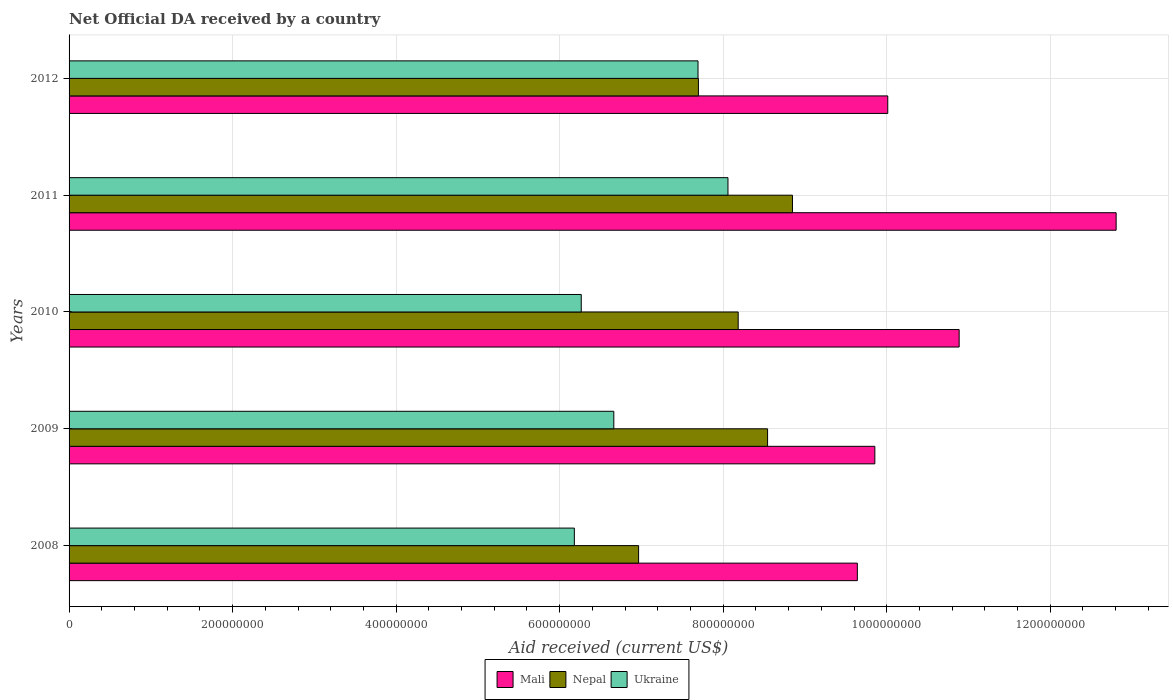How many different coloured bars are there?
Offer a terse response. 3. How many groups of bars are there?
Keep it short and to the point. 5. Are the number of bars per tick equal to the number of legend labels?
Provide a succinct answer. Yes. Are the number of bars on each tick of the Y-axis equal?
Provide a succinct answer. Yes. How many bars are there on the 4th tick from the bottom?
Keep it short and to the point. 3. What is the net official development assistance aid received in Ukraine in 2012?
Your response must be concise. 7.69e+08. Across all years, what is the maximum net official development assistance aid received in Nepal?
Your answer should be compact. 8.85e+08. Across all years, what is the minimum net official development assistance aid received in Ukraine?
Offer a very short reply. 6.18e+08. What is the total net official development assistance aid received in Ukraine in the graph?
Give a very brief answer. 3.49e+09. What is the difference between the net official development assistance aid received in Mali in 2008 and that in 2012?
Offer a terse response. -3.72e+07. What is the difference between the net official development assistance aid received in Mali in 2011 and the net official development assistance aid received in Nepal in 2012?
Your answer should be very brief. 5.11e+08. What is the average net official development assistance aid received in Mali per year?
Your answer should be very brief. 1.06e+09. In the year 2010, what is the difference between the net official development assistance aid received in Ukraine and net official development assistance aid received in Mali?
Your response must be concise. -4.62e+08. What is the ratio of the net official development assistance aid received in Mali in 2011 to that in 2012?
Your answer should be very brief. 1.28. Is the difference between the net official development assistance aid received in Ukraine in 2008 and 2012 greater than the difference between the net official development assistance aid received in Mali in 2008 and 2012?
Your response must be concise. No. What is the difference between the highest and the second highest net official development assistance aid received in Ukraine?
Ensure brevity in your answer.  3.66e+07. What is the difference between the highest and the lowest net official development assistance aid received in Ukraine?
Offer a terse response. 1.88e+08. In how many years, is the net official development assistance aid received in Mali greater than the average net official development assistance aid received in Mali taken over all years?
Your response must be concise. 2. Is the sum of the net official development assistance aid received in Mali in 2009 and 2011 greater than the maximum net official development assistance aid received in Ukraine across all years?
Offer a terse response. Yes. What does the 1st bar from the top in 2012 represents?
Provide a short and direct response. Ukraine. What does the 1st bar from the bottom in 2009 represents?
Offer a very short reply. Mali. Is it the case that in every year, the sum of the net official development assistance aid received in Ukraine and net official development assistance aid received in Nepal is greater than the net official development assistance aid received in Mali?
Keep it short and to the point. Yes. How many bars are there?
Your answer should be compact. 15. Are all the bars in the graph horizontal?
Keep it short and to the point. Yes. What is the difference between two consecutive major ticks on the X-axis?
Make the answer very short. 2.00e+08. Does the graph contain grids?
Your answer should be compact. Yes. How many legend labels are there?
Ensure brevity in your answer.  3. What is the title of the graph?
Make the answer very short. Net Official DA received by a country. Does "Cote d'Ivoire" appear as one of the legend labels in the graph?
Your answer should be compact. No. What is the label or title of the X-axis?
Give a very brief answer. Aid received (current US$). What is the Aid received (current US$) in Mali in 2008?
Ensure brevity in your answer.  9.64e+08. What is the Aid received (current US$) of Nepal in 2008?
Provide a short and direct response. 6.97e+08. What is the Aid received (current US$) in Ukraine in 2008?
Keep it short and to the point. 6.18e+08. What is the Aid received (current US$) of Mali in 2009?
Provide a succinct answer. 9.85e+08. What is the Aid received (current US$) of Nepal in 2009?
Give a very brief answer. 8.54e+08. What is the Aid received (current US$) of Ukraine in 2009?
Give a very brief answer. 6.66e+08. What is the Aid received (current US$) of Mali in 2010?
Give a very brief answer. 1.09e+09. What is the Aid received (current US$) in Nepal in 2010?
Provide a succinct answer. 8.18e+08. What is the Aid received (current US$) in Ukraine in 2010?
Ensure brevity in your answer.  6.26e+08. What is the Aid received (current US$) of Mali in 2011?
Make the answer very short. 1.28e+09. What is the Aid received (current US$) in Nepal in 2011?
Provide a succinct answer. 8.85e+08. What is the Aid received (current US$) in Ukraine in 2011?
Your answer should be very brief. 8.06e+08. What is the Aid received (current US$) in Mali in 2012?
Your answer should be compact. 1.00e+09. What is the Aid received (current US$) in Nepal in 2012?
Your response must be concise. 7.70e+08. What is the Aid received (current US$) in Ukraine in 2012?
Give a very brief answer. 7.69e+08. Across all years, what is the maximum Aid received (current US$) of Mali?
Your response must be concise. 1.28e+09. Across all years, what is the maximum Aid received (current US$) of Nepal?
Make the answer very short. 8.85e+08. Across all years, what is the maximum Aid received (current US$) in Ukraine?
Make the answer very short. 8.06e+08. Across all years, what is the minimum Aid received (current US$) of Mali?
Provide a short and direct response. 9.64e+08. Across all years, what is the minimum Aid received (current US$) of Nepal?
Your answer should be compact. 6.97e+08. Across all years, what is the minimum Aid received (current US$) in Ukraine?
Offer a very short reply. 6.18e+08. What is the total Aid received (current US$) in Mali in the graph?
Your answer should be very brief. 5.32e+09. What is the total Aid received (current US$) in Nepal in the graph?
Provide a short and direct response. 4.02e+09. What is the total Aid received (current US$) in Ukraine in the graph?
Keep it short and to the point. 3.49e+09. What is the difference between the Aid received (current US$) in Mali in 2008 and that in 2009?
Provide a short and direct response. -2.14e+07. What is the difference between the Aid received (current US$) of Nepal in 2008 and that in 2009?
Give a very brief answer. -1.58e+08. What is the difference between the Aid received (current US$) in Ukraine in 2008 and that in 2009?
Offer a terse response. -4.83e+07. What is the difference between the Aid received (current US$) in Mali in 2008 and that in 2010?
Your response must be concise. -1.25e+08. What is the difference between the Aid received (current US$) of Nepal in 2008 and that in 2010?
Your response must be concise. -1.22e+08. What is the difference between the Aid received (current US$) of Ukraine in 2008 and that in 2010?
Provide a short and direct response. -8.44e+06. What is the difference between the Aid received (current US$) of Mali in 2008 and that in 2011?
Provide a succinct answer. -3.17e+08. What is the difference between the Aid received (current US$) in Nepal in 2008 and that in 2011?
Your answer should be very brief. -1.88e+08. What is the difference between the Aid received (current US$) in Ukraine in 2008 and that in 2011?
Offer a terse response. -1.88e+08. What is the difference between the Aid received (current US$) in Mali in 2008 and that in 2012?
Your answer should be compact. -3.72e+07. What is the difference between the Aid received (current US$) in Nepal in 2008 and that in 2012?
Your answer should be compact. -7.32e+07. What is the difference between the Aid received (current US$) in Ukraine in 2008 and that in 2012?
Offer a terse response. -1.51e+08. What is the difference between the Aid received (current US$) of Mali in 2009 and that in 2010?
Offer a terse response. -1.03e+08. What is the difference between the Aid received (current US$) of Nepal in 2009 and that in 2010?
Give a very brief answer. 3.60e+07. What is the difference between the Aid received (current US$) of Ukraine in 2009 and that in 2010?
Offer a terse response. 3.98e+07. What is the difference between the Aid received (current US$) of Mali in 2009 and that in 2011?
Your answer should be compact. -2.95e+08. What is the difference between the Aid received (current US$) in Nepal in 2009 and that in 2011?
Keep it short and to the point. -3.04e+07. What is the difference between the Aid received (current US$) in Ukraine in 2009 and that in 2011?
Ensure brevity in your answer.  -1.40e+08. What is the difference between the Aid received (current US$) of Mali in 2009 and that in 2012?
Keep it short and to the point. -1.58e+07. What is the difference between the Aid received (current US$) of Nepal in 2009 and that in 2012?
Your response must be concise. 8.46e+07. What is the difference between the Aid received (current US$) in Ukraine in 2009 and that in 2012?
Your answer should be compact. -1.03e+08. What is the difference between the Aid received (current US$) in Mali in 2010 and that in 2011?
Make the answer very short. -1.92e+08. What is the difference between the Aid received (current US$) of Nepal in 2010 and that in 2011?
Provide a succinct answer. -6.64e+07. What is the difference between the Aid received (current US$) of Ukraine in 2010 and that in 2011?
Provide a succinct answer. -1.79e+08. What is the difference between the Aid received (current US$) of Mali in 2010 and that in 2012?
Offer a very short reply. 8.73e+07. What is the difference between the Aid received (current US$) of Nepal in 2010 and that in 2012?
Give a very brief answer. 4.86e+07. What is the difference between the Aid received (current US$) of Ukraine in 2010 and that in 2012?
Offer a terse response. -1.43e+08. What is the difference between the Aid received (current US$) in Mali in 2011 and that in 2012?
Give a very brief answer. 2.79e+08. What is the difference between the Aid received (current US$) in Nepal in 2011 and that in 2012?
Offer a terse response. 1.15e+08. What is the difference between the Aid received (current US$) of Ukraine in 2011 and that in 2012?
Provide a short and direct response. 3.66e+07. What is the difference between the Aid received (current US$) of Mali in 2008 and the Aid received (current US$) of Nepal in 2009?
Ensure brevity in your answer.  1.10e+08. What is the difference between the Aid received (current US$) of Mali in 2008 and the Aid received (current US$) of Ukraine in 2009?
Provide a short and direct response. 2.98e+08. What is the difference between the Aid received (current US$) in Nepal in 2008 and the Aid received (current US$) in Ukraine in 2009?
Give a very brief answer. 3.03e+07. What is the difference between the Aid received (current US$) of Mali in 2008 and the Aid received (current US$) of Nepal in 2010?
Offer a very short reply. 1.46e+08. What is the difference between the Aid received (current US$) of Mali in 2008 and the Aid received (current US$) of Ukraine in 2010?
Give a very brief answer. 3.38e+08. What is the difference between the Aid received (current US$) of Nepal in 2008 and the Aid received (current US$) of Ukraine in 2010?
Your answer should be compact. 7.02e+07. What is the difference between the Aid received (current US$) of Mali in 2008 and the Aid received (current US$) of Nepal in 2011?
Make the answer very short. 7.94e+07. What is the difference between the Aid received (current US$) in Mali in 2008 and the Aid received (current US$) in Ukraine in 2011?
Provide a short and direct response. 1.58e+08. What is the difference between the Aid received (current US$) of Nepal in 2008 and the Aid received (current US$) of Ukraine in 2011?
Offer a terse response. -1.09e+08. What is the difference between the Aid received (current US$) in Mali in 2008 and the Aid received (current US$) in Nepal in 2012?
Give a very brief answer. 1.94e+08. What is the difference between the Aid received (current US$) in Mali in 2008 and the Aid received (current US$) in Ukraine in 2012?
Offer a very short reply. 1.95e+08. What is the difference between the Aid received (current US$) in Nepal in 2008 and the Aid received (current US$) in Ukraine in 2012?
Offer a terse response. -7.27e+07. What is the difference between the Aid received (current US$) of Mali in 2009 and the Aid received (current US$) of Nepal in 2010?
Keep it short and to the point. 1.67e+08. What is the difference between the Aid received (current US$) in Mali in 2009 and the Aid received (current US$) in Ukraine in 2010?
Keep it short and to the point. 3.59e+08. What is the difference between the Aid received (current US$) in Nepal in 2009 and the Aid received (current US$) in Ukraine in 2010?
Give a very brief answer. 2.28e+08. What is the difference between the Aid received (current US$) of Mali in 2009 and the Aid received (current US$) of Nepal in 2011?
Make the answer very short. 1.01e+08. What is the difference between the Aid received (current US$) of Mali in 2009 and the Aid received (current US$) of Ukraine in 2011?
Your response must be concise. 1.80e+08. What is the difference between the Aid received (current US$) of Nepal in 2009 and the Aid received (current US$) of Ukraine in 2011?
Make the answer very short. 4.84e+07. What is the difference between the Aid received (current US$) in Mali in 2009 and the Aid received (current US$) in Nepal in 2012?
Your answer should be very brief. 2.16e+08. What is the difference between the Aid received (current US$) of Mali in 2009 and the Aid received (current US$) of Ukraine in 2012?
Offer a terse response. 2.16e+08. What is the difference between the Aid received (current US$) of Nepal in 2009 and the Aid received (current US$) of Ukraine in 2012?
Your answer should be very brief. 8.51e+07. What is the difference between the Aid received (current US$) of Mali in 2010 and the Aid received (current US$) of Nepal in 2011?
Your answer should be compact. 2.04e+08. What is the difference between the Aid received (current US$) in Mali in 2010 and the Aid received (current US$) in Ukraine in 2011?
Make the answer very short. 2.83e+08. What is the difference between the Aid received (current US$) of Nepal in 2010 and the Aid received (current US$) of Ukraine in 2011?
Offer a terse response. 1.25e+07. What is the difference between the Aid received (current US$) in Mali in 2010 and the Aid received (current US$) in Nepal in 2012?
Give a very brief answer. 3.19e+08. What is the difference between the Aid received (current US$) of Mali in 2010 and the Aid received (current US$) of Ukraine in 2012?
Ensure brevity in your answer.  3.19e+08. What is the difference between the Aid received (current US$) of Nepal in 2010 and the Aid received (current US$) of Ukraine in 2012?
Make the answer very short. 4.91e+07. What is the difference between the Aid received (current US$) in Mali in 2011 and the Aid received (current US$) in Nepal in 2012?
Give a very brief answer. 5.11e+08. What is the difference between the Aid received (current US$) of Mali in 2011 and the Aid received (current US$) of Ukraine in 2012?
Give a very brief answer. 5.11e+08. What is the difference between the Aid received (current US$) in Nepal in 2011 and the Aid received (current US$) in Ukraine in 2012?
Ensure brevity in your answer.  1.16e+08. What is the average Aid received (current US$) of Mali per year?
Make the answer very short. 1.06e+09. What is the average Aid received (current US$) in Nepal per year?
Give a very brief answer. 8.05e+08. What is the average Aid received (current US$) in Ukraine per year?
Ensure brevity in your answer.  6.97e+08. In the year 2008, what is the difference between the Aid received (current US$) in Mali and Aid received (current US$) in Nepal?
Your response must be concise. 2.68e+08. In the year 2008, what is the difference between the Aid received (current US$) of Mali and Aid received (current US$) of Ukraine?
Keep it short and to the point. 3.46e+08. In the year 2008, what is the difference between the Aid received (current US$) of Nepal and Aid received (current US$) of Ukraine?
Make the answer very short. 7.86e+07. In the year 2009, what is the difference between the Aid received (current US$) in Mali and Aid received (current US$) in Nepal?
Offer a terse response. 1.31e+08. In the year 2009, what is the difference between the Aid received (current US$) in Mali and Aid received (current US$) in Ukraine?
Your response must be concise. 3.19e+08. In the year 2009, what is the difference between the Aid received (current US$) of Nepal and Aid received (current US$) of Ukraine?
Your answer should be compact. 1.88e+08. In the year 2010, what is the difference between the Aid received (current US$) of Mali and Aid received (current US$) of Nepal?
Your answer should be very brief. 2.70e+08. In the year 2010, what is the difference between the Aid received (current US$) of Mali and Aid received (current US$) of Ukraine?
Your response must be concise. 4.62e+08. In the year 2010, what is the difference between the Aid received (current US$) in Nepal and Aid received (current US$) in Ukraine?
Your answer should be very brief. 1.92e+08. In the year 2011, what is the difference between the Aid received (current US$) in Mali and Aid received (current US$) in Nepal?
Keep it short and to the point. 3.96e+08. In the year 2011, what is the difference between the Aid received (current US$) in Mali and Aid received (current US$) in Ukraine?
Your answer should be compact. 4.75e+08. In the year 2011, what is the difference between the Aid received (current US$) of Nepal and Aid received (current US$) of Ukraine?
Make the answer very short. 7.89e+07. In the year 2012, what is the difference between the Aid received (current US$) in Mali and Aid received (current US$) in Nepal?
Offer a very short reply. 2.32e+08. In the year 2012, what is the difference between the Aid received (current US$) in Mali and Aid received (current US$) in Ukraine?
Keep it short and to the point. 2.32e+08. What is the ratio of the Aid received (current US$) in Mali in 2008 to that in 2009?
Give a very brief answer. 0.98. What is the ratio of the Aid received (current US$) of Nepal in 2008 to that in 2009?
Ensure brevity in your answer.  0.82. What is the ratio of the Aid received (current US$) in Ukraine in 2008 to that in 2009?
Offer a very short reply. 0.93. What is the ratio of the Aid received (current US$) of Mali in 2008 to that in 2010?
Offer a very short reply. 0.89. What is the ratio of the Aid received (current US$) in Nepal in 2008 to that in 2010?
Your response must be concise. 0.85. What is the ratio of the Aid received (current US$) in Ukraine in 2008 to that in 2010?
Your response must be concise. 0.99. What is the ratio of the Aid received (current US$) of Mali in 2008 to that in 2011?
Your answer should be very brief. 0.75. What is the ratio of the Aid received (current US$) of Nepal in 2008 to that in 2011?
Provide a succinct answer. 0.79. What is the ratio of the Aid received (current US$) in Ukraine in 2008 to that in 2011?
Your answer should be very brief. 0.77. What is the ratio of the Aid received (current US$) in Mali in 2008 to that in 2012?
Keep it short and to the point. 0.96. What is the ratio of the Aid received (current US$) in Nepal in 2008 to that in 2012?
Give a very brief answer. 0.91. What is the ratio of the Aid received (current US$) in Ukraine in 2008 to that in 2012?
Give a very brief answer. 0.8. What is the ratio of the Aid received (current US$) in Mali in 2009 to that in 2010?
Offer a terse response. 0.91. What is the ratio of the Aid received (current US$) of Nepal in 2009 to that in 2010?
Your answer should be very brief. 1.04. What is the ratio of the Aid received (current US$) of Ukraine in 2009 to that in 2010?
Keep it short and to the point. 1.06. What is the ratio of the Aid received (current US$) of Mali in 2009 to that in 2011?
Make the answer very short. 0.77. What is the ratio of the Aid received (current US$) of Nepal in 2009 to that in 2011?
Provide a short and direct response. 0.97. What is the ratio of the Aid received (current US$) in Ukraine in 2009 to that in 2011?
Provide a succinct answer. 0.83. What is the ratio of the Aid received (current US$) of Mali in 2009 to that in 2012?
Offer a terse response. 0.98. What is the ratio of the Aid received (current US$) in Nepal in 2009 to that in 2012?
Your response must be concise. 1.11. What is the ratio of the Aid received (current US$) in Ukraine in 2009 to that in 2012?
Your answer should be compact. 0.87. What is the ratio of the Aid received (current US$) of Mali in 2010 to that in 2011?
Keep it short and to the point. 0.85. What is the ratio of the Aid received (current US$) of Nepal in 2010 to that in 2011?
Offer a very short reply. 0.93. What is the ratio of the Aid received (current US$) in Ukraine in 2010 to that in 2011?
Your answer should be compact. 0.78. What is the ratio of the Aid received (current US$) in Mali in 2010 to that in 2012?
Offer a terse response. 1.09. What is the ratio of the Aid received (current US$) in Nepal in 2010 to that in 2012?
Your answer should be very brief. 1.06. What is the ratio of the Aid received (current US$) of Ukraine in 2010 to that in 2012?
Give a very brief answer. 0.81. What is the ratio of the Aid received (current US$) of Mali in 2011 to that in 2012?
Make the answer very short. 1.28. What is the ratio of the Aid received (current US$) of Nepal in 2011 to that in 2012?
Your response must be concise. 1.15. What is the ratio of the Aid received (current US$) of Ukraine in 2011 to that in 2012?
Offer a very short reply. 1.05. What is the difference between the highest and the second highest Aid received (current US$) in Mali?
Offer a terse response. 1.92e+08. What is the difference between the highest and the second highest Aid received (current US$) in Nepal?
Your answer should be very brief. 3.04e+07. What is the difference between the highest and the second highest Aid received (current US$) of Ukraine?
Provide a short and direct response. 3.66e+07. What is the difference between the highest and the lowest Aid received (current US$) in Mali?
Ensure brevity in your answer.  3.17e+08. What is the difference between the highest and the lowest Aid received (current US$) of Nepal?
Offer a very short reply. 1.88e+08. What is the difference between the highest and the lowest Aid received (current US$) in Ukraine?
Offer a very short reply. 1.88e+08. 